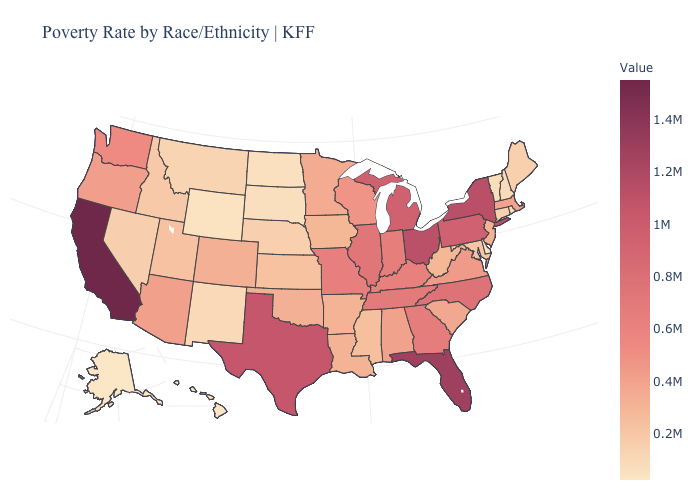Is the legend a continuous bar?
Short answer required. Yes. Is the legend a continuous bar?
Concise answer only. Yes. Does Texas have a lower value than California?
Quick response, please. Yes. Which states have the lowest value in the West?
Be succinct. Alaska. 